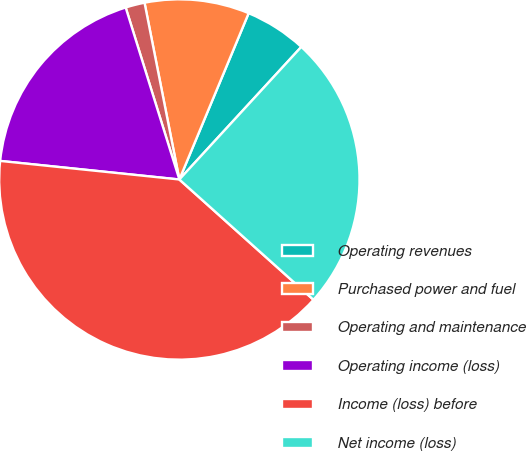<chart> <loc_0><loc_0><loc_500><loc_500><pie_chart><fcel>Operating revenues<fcel>Purchased power and fuel<fcel>Operating and maintenance<fcel>Operating income (loss)<fcel>Income (loss) before<fcel>Net income (loss)<nl><fcel>5.55%<fcel>9.38%<fcel>1.72%<fcel>18.54%<fcel>40.01%<fcel>24.8%<nl></chart> 